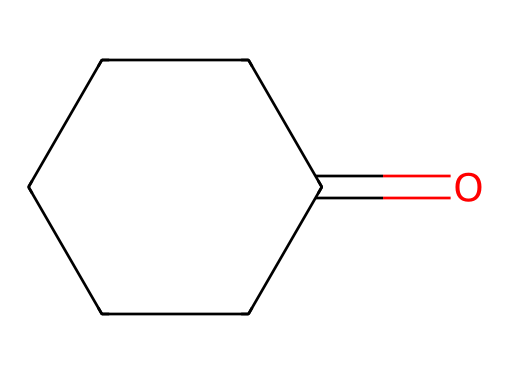What is the chemical name of the compound represented by the SMILES? The SMILES notation shows a ketone structure with a cyclic arrangement, specifically carbon atoms forming a ring with a carbonyl (C=O). The molecular structure corresponds to cyclohexanone.
Answer: cyclohexanone How many carbon atoms are in cyclohexanone? The SMILES reveals that there are six carbon atoms in the ring structure (C1CCCCC1 indicates a six-membered ring).
Answer: six What type of functional group is present in cyclohexanone? The presence of the carbonyl group (C=O) in the SMILES indicates that cyclohexanone has a ketone functional group.
Answer: ketone What is the number of hydrogen atoms in cyclohexanone? In cyclohexanone, there are 10 hydrogen atoms assigned to the carbons in the ring and one less due to the carbonyl; thus, the formula is C6H10O.
Answer: ten Is cyclohexanone a saturated or unsaturated compound? The carbon atom count and the presence of a carbonyl group (C=O) imply cyclohexanone is saturated since it has no double bonds between the carbon atoms in the ring itself; it satisfies the tetravalency rules without extra unsaturation.
Answer: saturated What is the significance of cyclohexanone in industry? Cyclohexanone is widely used as a solvent and a precursor in the production of nylon, especially for outdoor gear, highlighting its importance in material sciences and practical applications.
Answer: nylon production 